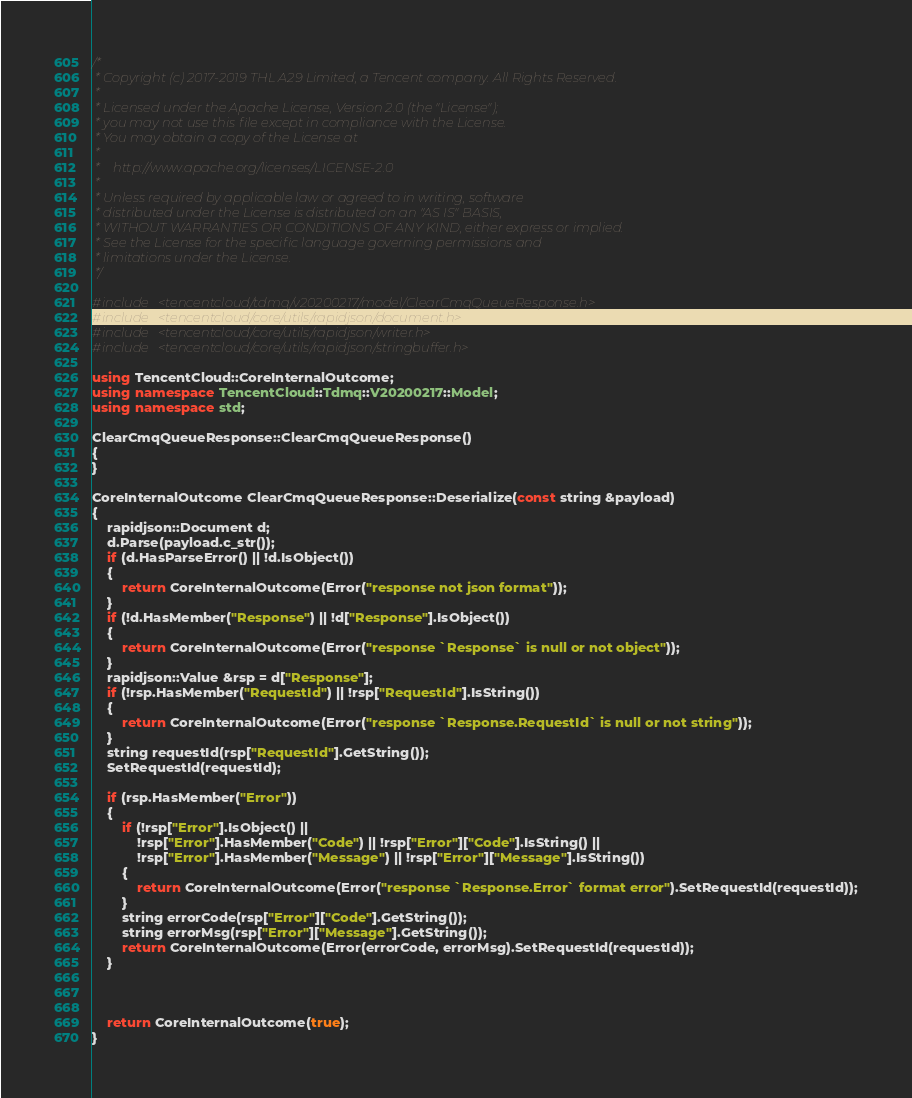Convert code to text. <code><loc_0><loc_0><loc_500><loc_500><_C++_>/*
 * Copyright (c) 2017-2019 THL A29 Limited, a Tencent company. All Rights Reserved.
 *
 * Licensed under the Apache License, Version 2.0 (the "License");
 * you may not use this file except in compliance with the License.
 * You may obtain a copy of the License at
 *
 *    http://www.apache.org/licenses/LICENSE-2.0
 *
 * Unless required by applicable law or agreed to in writing, software
 * distributed under the License is distributed on an "AS IS" BASIS,
 * WITHOUT WARRANTIES OR CONDITIONS OF ANY KIND, either express or implied.
 * See the License for the specific language governing permissions and
 * limitations under the License.
 */

#include <tencentcloud/tdmq/v20200217/model/ClearCmqQueueResponse.h>
#include <tencentcloud/core/utils/rapidjson/document.h>
#include <tencentcloud/core/utils/rapidjson/writer.h>
#include <tencentcloud/core/utils/rapidjson/stringbuffer.h>

using TencentCloud::CoreInternalOutcome;
using namespace TencentCloud::Tdmq::V20200217::Model;
using namespace std;

ClearCmqQueueResponse::ClearCmqQueueResponse()
{
}

CoreInternalOutcome ClearCmqQueueResponse::Deserialize(const string &payload)
{
    rapidjson::Document d;
    d.Parse(payload.c_str());
    if (d.HasParseError() || !d.IsObject())
    {
        return CoreInternalOutcome(Error("response not json format"));
    }
    if (!d.HasMember("Response") || !d["Response"].IsObject())
    {
        return CoreInternalOutcome(Error("response `Response` is null or not object"));
    }
    rapidjson::Value &rsp = d["Response"];
    if (!rsp.HasMember("RequestId") || !rsp["RequestId"].IsString())
    {
        return CoreInternalOutcome(Error("response `Response.RequestId` is null or not string"));
    }
    string requestId(rsp["RequestId"].GetString());
    SetRequestId(requestId);

    if (rsp.HasMember("Error"))
    {
        if (!rsp["Error"].IsObject() ||
            !rsp["Error"].HasMember("Code") || !rsp["Error"]["Code"].IsString() ||
            !rsp["Error"].HasMember("Message") || !rsp["Error"]["Message"].IsString())
        {
            return CoreInternalOutcome(Error("response `Response.Error` format error").SetRequestId(requestId));
        }
        string errorCode(rsp["Error"]["Code"].GetString());
        string errorMsg(rsp["Error"]["Message"].GetString());
        return CoreInternalOutcome(Error(errorCode, errorMsg).SetRequestId(requestId));
    }



    return CoreInternalOutcome(true);
}



</code> 